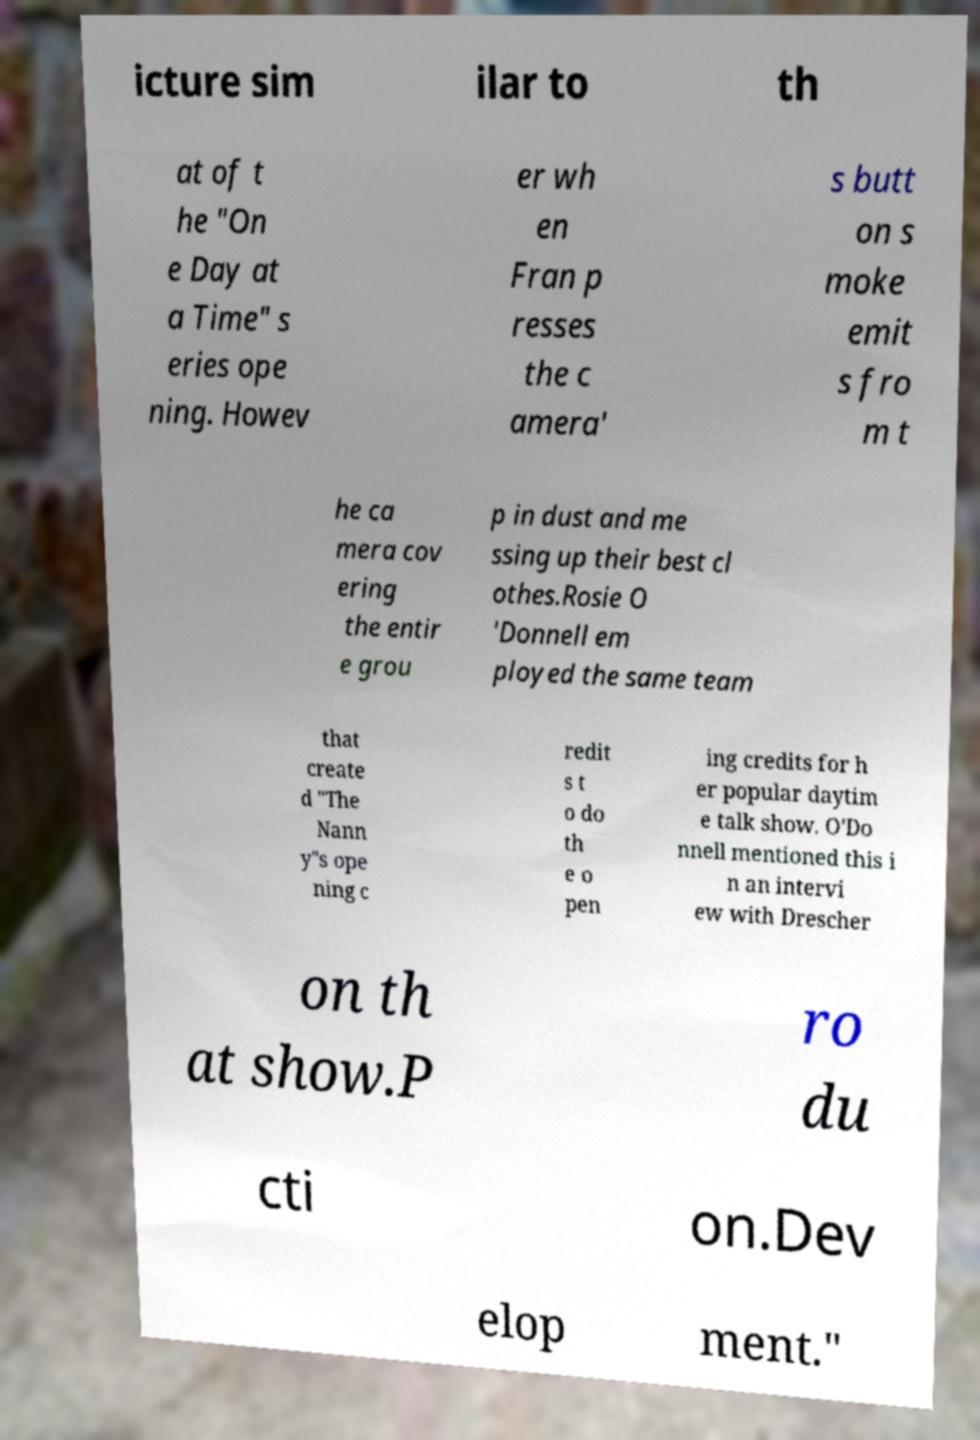Please read and relay the text visible in this image. What does it say? icture sim ilar to th at of t he "On e Day at a Time" s eries ope ning. Howev er wh en Fran p resses the c amera' s butt on s moke emit s fro m t he ca mera cov ering the entir e grou p in dust and me ssing up their best cl othes.Rosie O 'Donnell em ployed the same team that create d "The Nann y"s ope ning c redit s t o do th e o pen ing credits for h er popular daytim e talk show. O'Do nnell mentioned this i n an intervi ew with Drescher on th at show.P ro du cti on.Dev elop ment." 